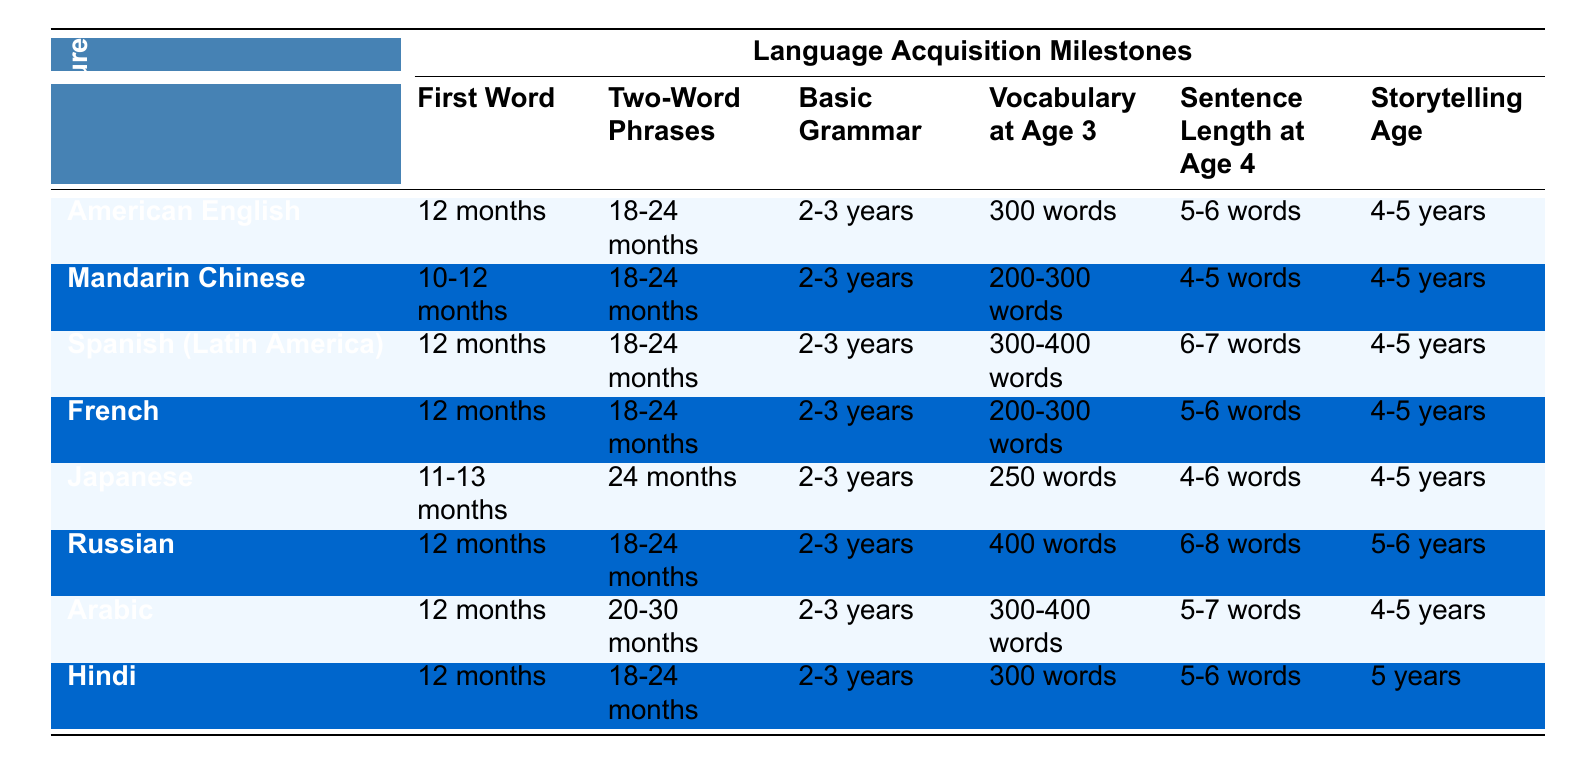What is the age for the first word in Mandarin Chinese? The table states that the first word age in Mandarin Chinese is listed as "10-12 months."
Answer: 10-12 months Which culture has the highest vocabulary at age 3? Looking at the vocabulary at age 3 column, the Russian culture lists "400 words," which is the highest compared to other cultures.
Answer: Russian What is the storytelling age for Hindi? According to the table, the storytelling age for Hindi is given as "5 years."
Answer: 5 years How many cultures have a first word age of 12 months? By counting the entries in the first word age column, there are five cultures listed: American English, Spanish, French, Russian, and Arabic, all at 12 months.
Answer: 5 Is the basic grammar age the same for all cultures? The table shows that all cultures have the same basic grammar age of "2-3 years," confirming that this fact is true.
Answer: Yes What is the difference in vocabulary at age 3 between American English and Mandarin Chinese? American English has "300 words" while Mandarin Chinese has "200-300 words." Taking the lower end from Mandarin, the difference is 300 - 200 = 100 words.
Answer: 100 words Which culture has the longest sentence length at age 4? Looking through the sentence length at age 4 column, Spanish (Latin America) has "6-7 words," which is the longest range compared to others mentioned.
Answer: 6-7 words How does the age for two-word phrases in Japanese compare to that of American English? Japanese has a two-word phrases age of "24 months," while American English has "18-24 months," which indicates Japanese begins later at 24 months.
Answer: Japanese starts later If we average the vocabulary at age 3 among Mandarin Chinese, French, and Spanish (Latin America), what would that be? Mandarin has 200-300 words (average of 250), French has 200-300 (average of 250), and Spanish has 300-400 (average of 350), so, (250 + 250 + 350) / 3 = 283.33 words, approximately 283 when expressed as a whole number.
Answer: 283 words Which cultures have a two-word phrases age listed above 24 months? From the table, Japanese and Arabic have a two-word phrases age of "24 months" and "20-30 months," respectively. Therefore, Japanese is exactly at 24 months, while Arabic is between 20 and 30 months, but no culture is above that age.
Answer: None above 24 months 